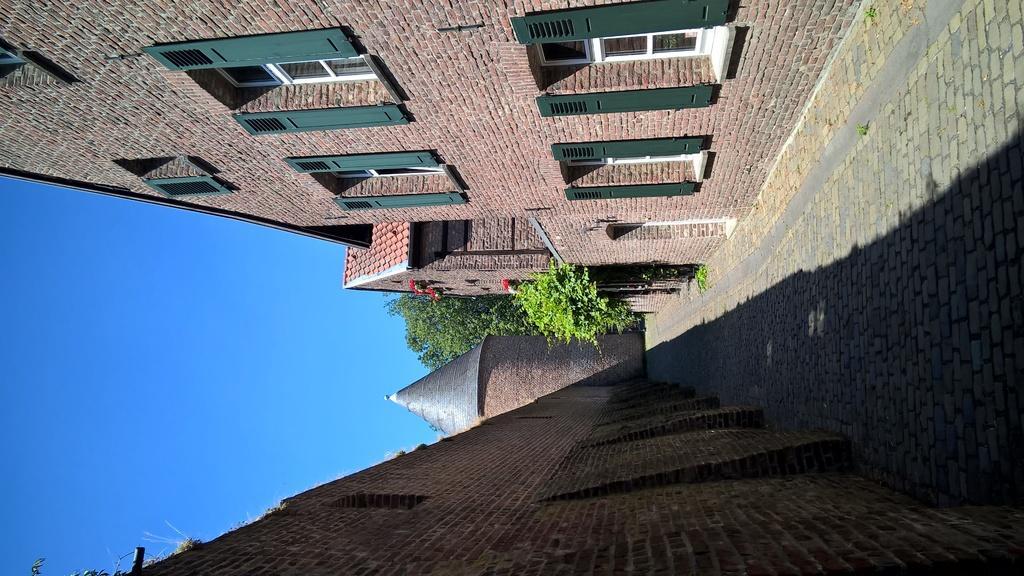In one or two sentences, can you explain what this image depicts? There are buildings which has green windows. There is a walkway in the center. There are trees at the back. 